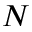<formula> <loc_0><loc_0><loc_500><loc_500>N</formula> 